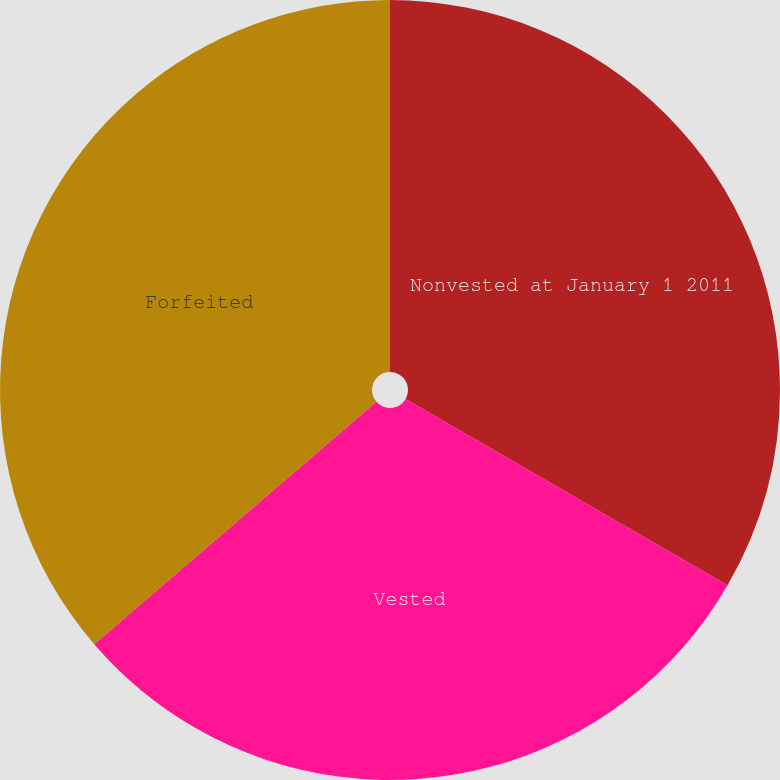Convert chart to OTSL. <chart><loc_0><loc_0><loc_500><loc_500><pie_chart><fcel>Nonvested at January 1 2011<fcel>Vested<fcel>Forfeited<nl><fcel>33.35%<fcel>30.35%<fcel>36.3%<nl></chart> 